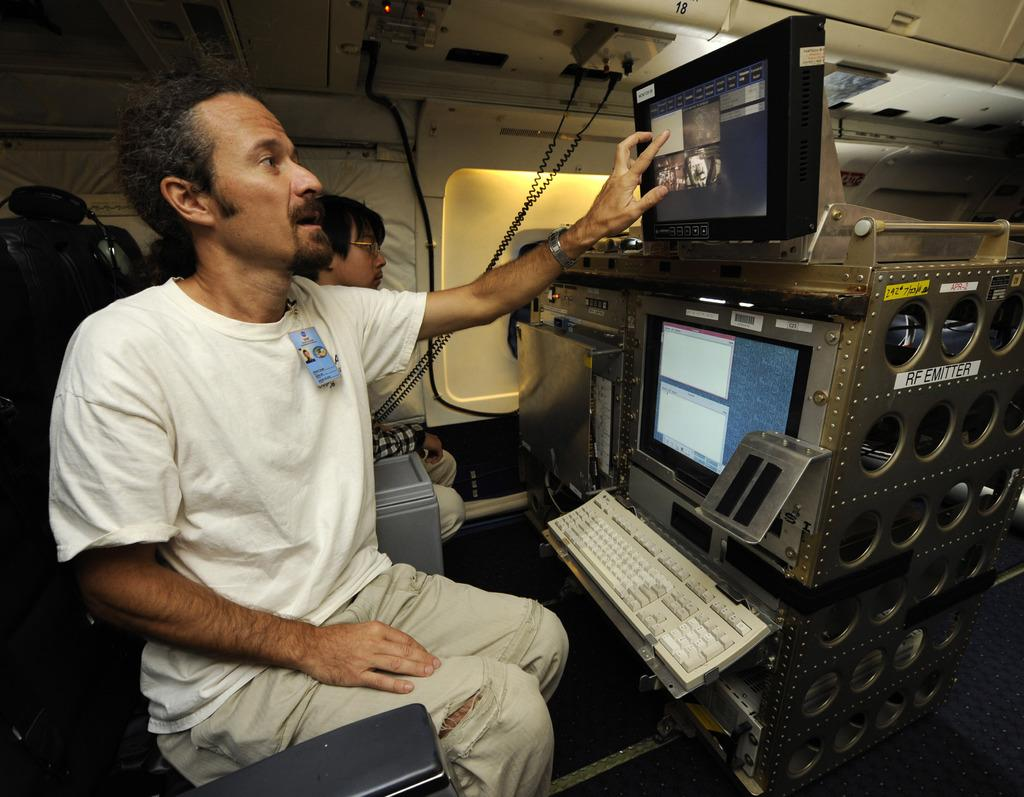<image>
Give a short and clear explanation of the subsequent image. A man in a white shirt sitting in front of a RF-Emitter computer. 